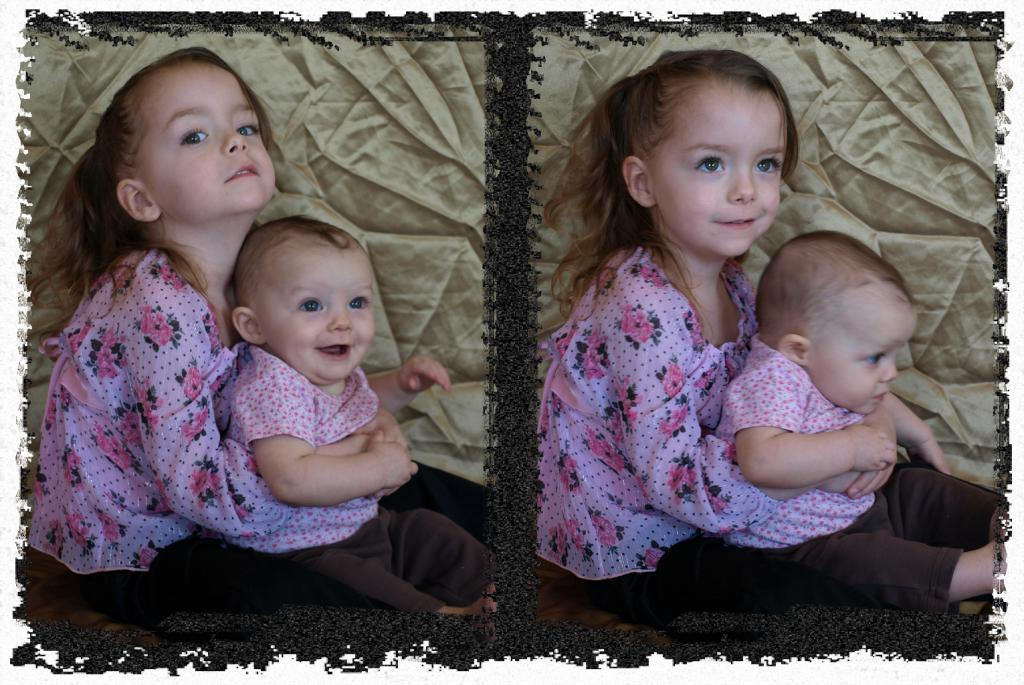What is the main subject of the image? There is a collage of two pictures in the image. What is happening in one of the pictures? A girl is holding a baby in the image. How is the girl holding the baby? The girl is holding the baby with her hands. What can be seen in the background of the image? There is a cloth visible in the background of the image. What type of cabbage is being used to make the pie in the image? There is no cabbage or pie present in the image; it features a collage of two pictures, one of which shows a girl holding a baby. 